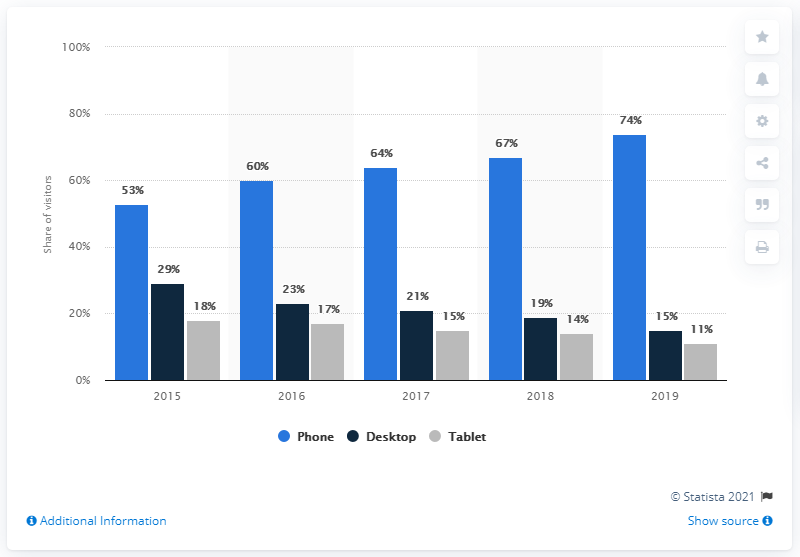Highlight a few significant elements in this photo. In 2019, it is estimated that approximately 74% of mobile users visited Pornhub. 